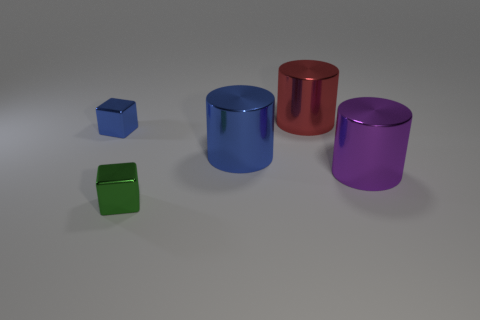Does the red object have the same size as the blue shiny object left of the green cube?
Give a very brief answer. No. How many purple shiny cylinders have the same size as the blue metallic cube?
Your response must be concise. 0. How many tiny objects are rubber cubes or red things?
Your response must be concise. 0. Are there any big cyan balls?
Ensure brevity in your answer.  No. Is the number of shiny cylinders on the left side of the large red shiny thing greater than the number of purple metal cylinders that are on the left side of the small blue shiny object?
Offer a terse response. Yes. There is a small metallic block that is behind the blue thing right of the small green shiny object; what is its color?
Your answer should be very brief. Blue. What is the size of the blue object that is to the left of the cube right of the tiny thing on the left side of the green metallic block?
Provide a succinct answer. Small. What shape is the large purple shiny object?
Provide a short and direct response. Cylinder. What number of large red objects are right of the block that is in front of the purple metallic object?
Give a very brief answer. 1. What number of other objects are there of the same material as the red cylinder?
Ensure brevity in your answer.  4. 